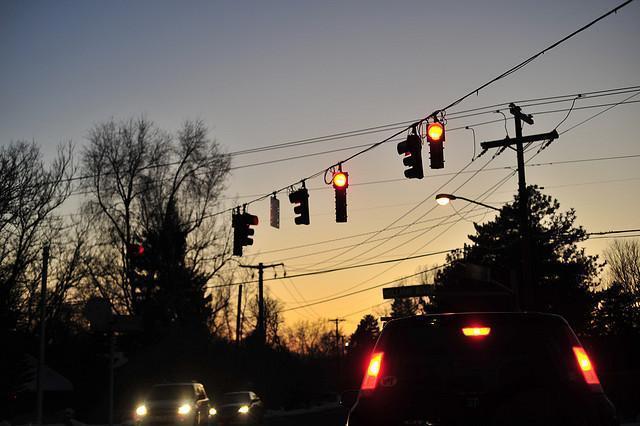How many cars are in the picture?
Give a very brief answer. 2. 